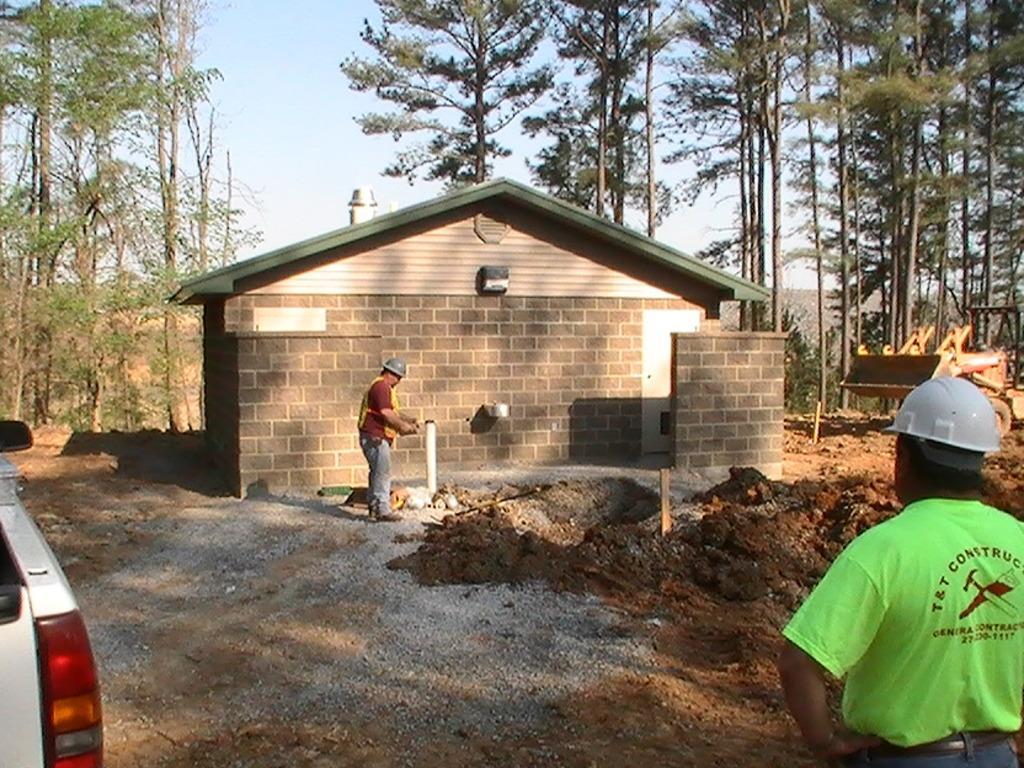How would you summarize this image in a sentence or two? In the image there are two men in hazard jacket and helmet standing on the land, behind there is a home with a chimney above it, in the background there are trees and above its sky, there is truck on the left side. 